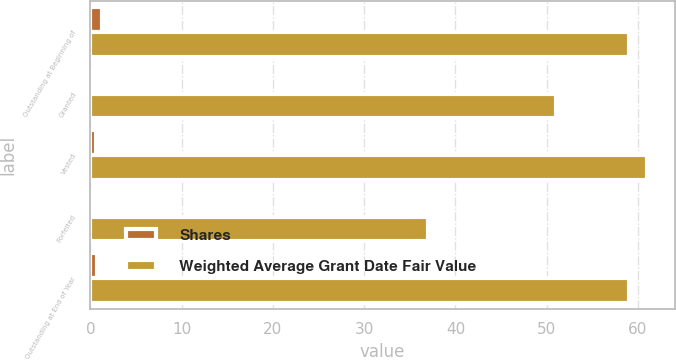Convert chart to OTSL. <chart><loc_0><loc_0><loc_500><loc_500><stacked_bar_chart><ecel><fcel>Outstanding at Beginning of<fcel>Granted<fcel>Vested<fcel>Forfeited<fcel>Outstanding at End of Year<nl><fcel>Shares<fcel>1.3<fcel>0.1<fcel>0.6<fcel>0.1<fcel>0.7<nl><fcel>Weighted Average Grant Date Fair Value<fcel>59<fcel>51<fcel>61<fcel>37<fcel>59<nl></chart> 